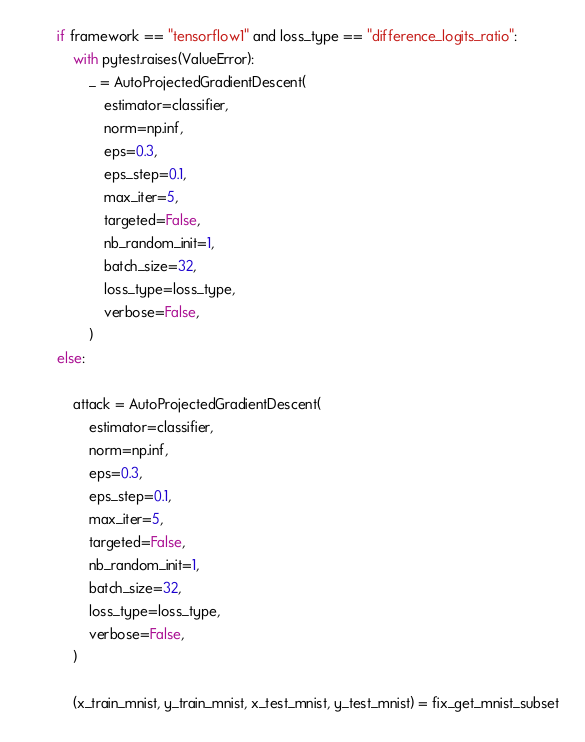Convert code to text. <code><loc_0><loc_0><loc_500><loc_500><_Python_>
        if framework == "tensorflow1" and loss_type == "difference_logits_ratio":
            with pytest.raises(ValueError):
                _ = AutoProjectedGradientDescent(
                    estimator=classifier,
                    norm=np.inf,
                    eps=0.3,
                    eps_step=0.1,
                    max_iter=5,
                    targeted=False,
                    nb_random_init=1,
                    batch_size=32,
                    loss_type=loss_type,
                    verbose=False,
                )
        else:

            attack = AutoProjectedGradientDescent(
                estimator=classifier,
                norm=np.inf,
                eps=0.3,
                eps_step=0.1,
                max_iter=5,
                targeted=False,
                nb_random_init=1,
                batch_size=32,
                loss_type=loss_type,
                verbose=False,
            )

            (x_train_mnist, y_train_mnist, x_test_mnist, y_test_mnist) = fix_get_mnist_subset
</code> 